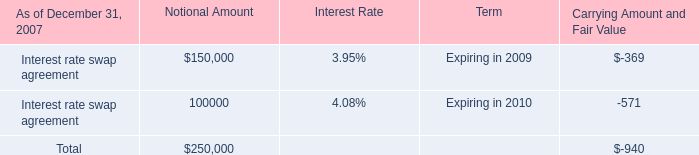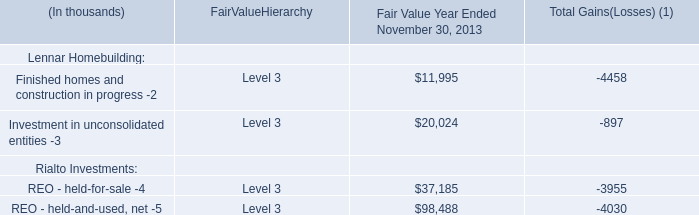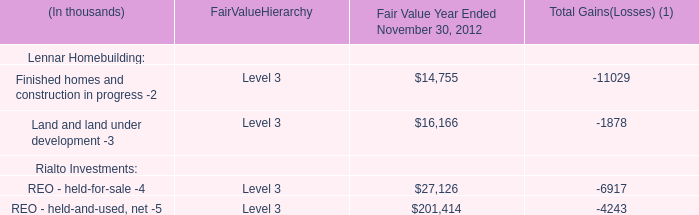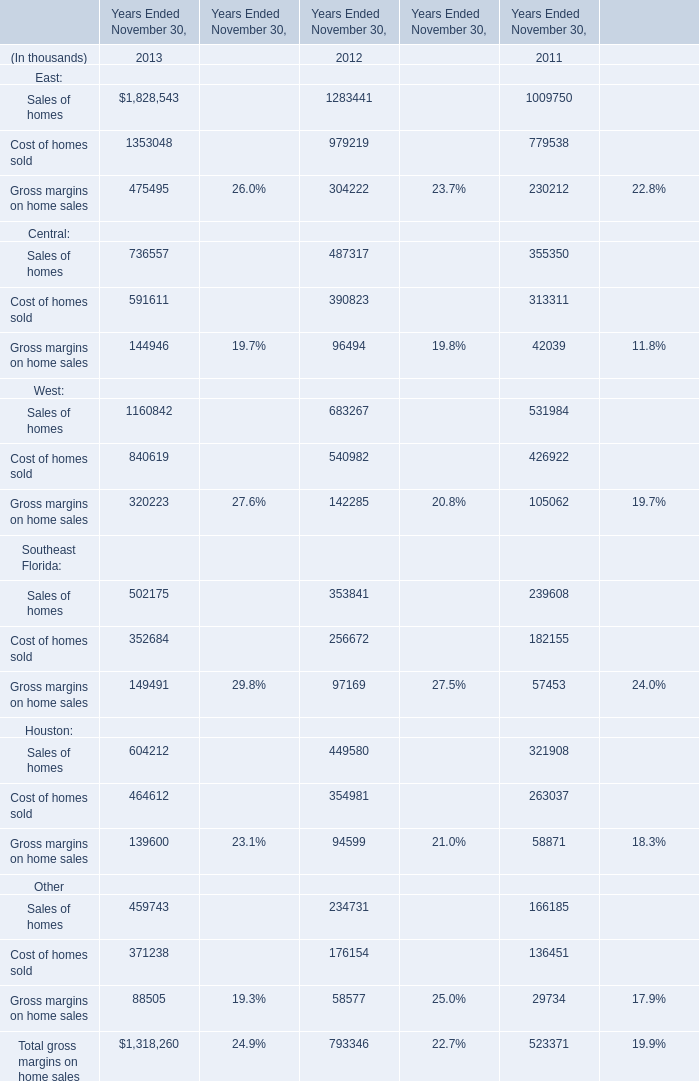what is the yearly amortization expense for the economic rights agreement assuming an 11 year effective life? 
Computations: ((30.2 / 11) * 1000000)
Answer: 2745454.54545. 